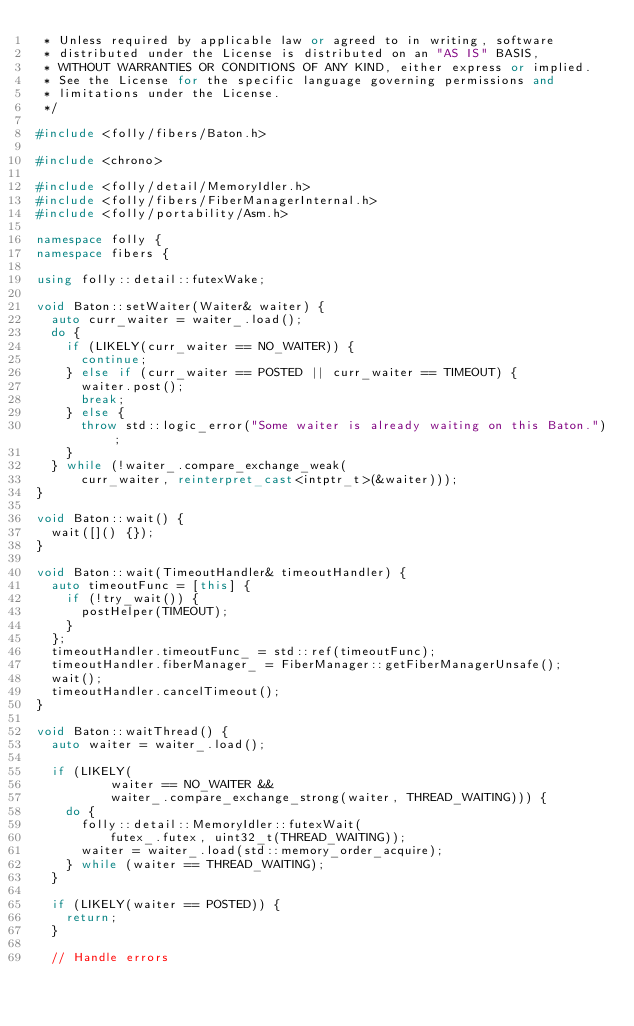Convert code to text. <code><loc_0><loc_0><loc_500><loc_500><_C++_> * Unless required by applicable law or agreed to in writing, software
 * distributed under the License is distributed on an "AS IS" BASIS,
 * WITHOUT WARRANTIES OR CONDITIONS OF ANY KIND, either express or implied.
 * See the License for the specific language governing permissions and
 * limitations under the License.
 */

#include <folly/fibers/Baton.h>

#include <chrono>

#include <folly/detail/MemoryIdler.h>
#include <folly/fibers/FiberManagerInternal.h>
#include <folly/portability/Asm.h>

namespace folly {
namespace fibers {

using folly::detail::futexWake;

void Baton::setWaiter(Waiter& waiter) {
  auto curr_waiter = waiter_.load();
  do {
    if (LIKELY(curr_waiter == NO_WAITER)) {
      continue;
    } else if (curr_waiter == POSTED || curr_waiter == TIMEOUT) {
      waiter.post();
      break;
    } else {
      throw std::logic_error("Some waiter is already waiting on this Baton.");
    }
  } while (!waiter_.compare_exchange_weak(
      curr_waiter, reinterpret_cast<intptr_t>(&waiter)));
}

void Baton::wait() {
  wait([]() {});
}

void Baton::wait(TimeoutHandler& timeoutHandler) {
  auto timeoutFunc = [this] {
    if (!try_wait()) {
      postHelper(TIMEOUT);
    }
  };
  timeoutHandler.timeoutFunc_ = std::ref(timeoutFunc);
  timeoutHandler.fiberManager_ = FiberManager::getFiberManagerUnsafe();
  wait();
  timeoutHandler.cancelTimeout();
}

void Baton::waitThread() {
  auto waiter = waiter_.load();

  if (LIKELY(
          waiter == NO_WAITER &&
          waiter_.compare_exchange_strong(waiter, THREAD_WAITING))) {
    do {
      folly::detail::MemoryIdler::futexWait(
          futex_.futex, uint32_t(THREAD_WAITING));
      waiter = waiter_.load(std::memory_order_acquire);
    } while (waiter == THREAD_WAITING);
  }

  if (LIKELY(waiter == POSTED)) {
    return;
  }

  // Handle errors</code> 